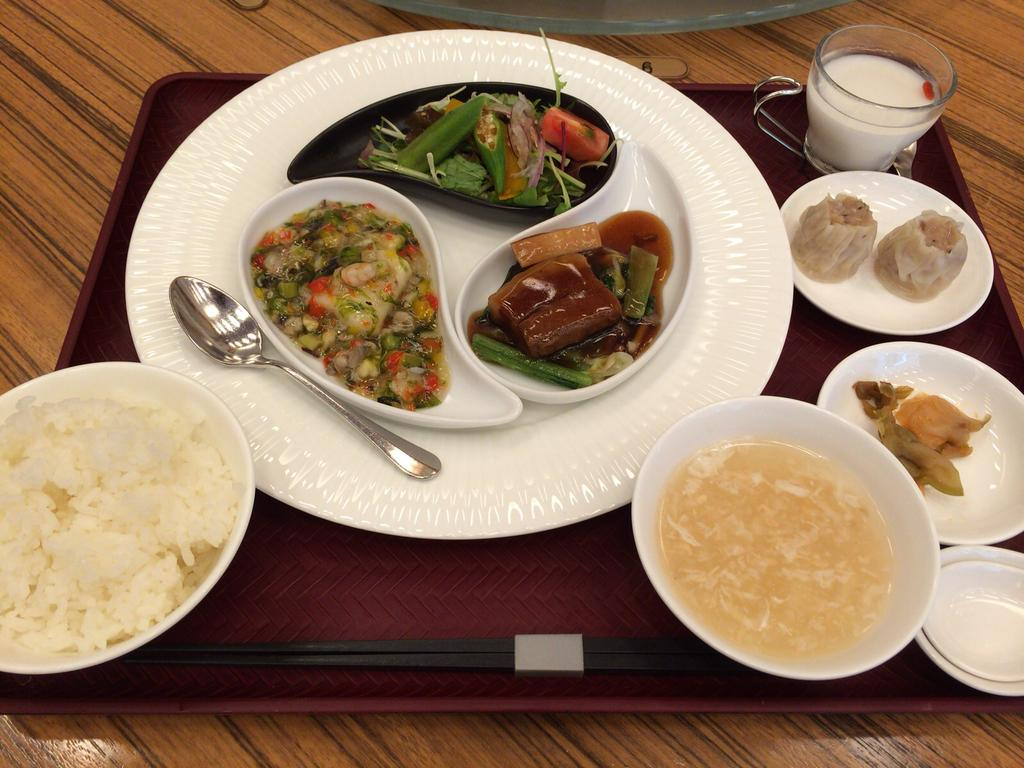What type of containers are used for the food items in the image? There are bowls and plates used for the food items in the image. What is the liquid-containing item in the image? There is a cup with liquid in the image. What utensil is present on the table in the image? There is a spoon on the table in the image. What type of quartz is used as a decorative element in the image? There is no quartz present in the image. How do the fairies interact with the food items in the image? There are no fairies present in the image. 